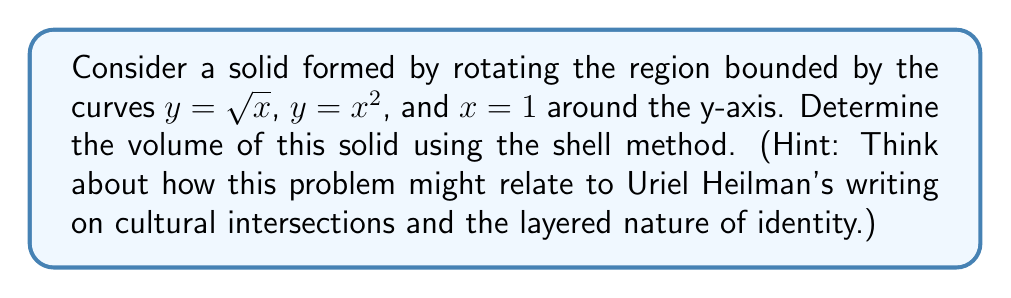Can you solve this math problem? To solve this problem, we'll use the shell method, which is particularly apt given the layered nature of cultural identity often discussed in Uriel Heilman's work.

1) First, let's visualize the region:

[asy]
import graph;
size(200);
real f(real x) {return sqrt(x);}
real g(real x) {return x^2;}
draw(graph(f,0,1),blue);
draw(graph(g,0,1),red);
draw((1,0)--(1,1),green);
label("$y=\sqrt{x}$",(0.5,0.7),NW,blue);
label("$y=x^2$",(0.7,0.5),SE,red);
label("$x=1$",(1,0.5),E,green);
xaxis("x",arrow=Arrow);
yaxis("y",arrow=Arrow);
[/asy]

2) The shell method formula for volume is:

   $$V = 2\pi \int_a^b y \cdot x \, dy$$

   where $x$ is a function of $y$.

3) We need to find the limits of integration. The curves intersect when:
   $$\sqrt{x} = x^2$$
   $$x = x^4$$
   $$x(1-x^3) = 0$$
   $$x = 0$$ or $$x = 1$$

   So, the limits are from $y = 0$ to $y = 1$.

4) Now, we need to express $x$ in terms of $y$. We have two functions:
   $$x = y^2$$ (from $y = \sqrt{x}$)
   $$x = \sqrt{y}$$ (from $y = x^2$)

5) Our integral becomes:
   $$V = 2\pi \int_0^1 y \cdot (y^2 - \sqrt{y}) \, dy$$

6) Expanding:
   $$V = 2\pi \int_0^1 (y^3 - y\sqrt{y}) \, dy$$

7) Integrating:
   $$V = 2\pi \left[\frac{y^4}{4} - \frac{2y^{7/2}}{7}\right]_0^1$$

8) Evaluating:
   $$V = 2\pi \left(\frac{1}{4} - \frac{2}{7}\right) = 2\pi \left(\frac{7}{28} - \frac{8}{28}\right) = -\frac{\pi}{14}$$

9) However, volume cannot be negative, so we take the absolute value:
   $$V = \frac{\pi}{14}$$

This layered approach to integration mirrors the complex, multi-faceted nature of cultural identity often explored in Heilman's writings.
Answer: $\frac{\pi}{14}$ cubic units 